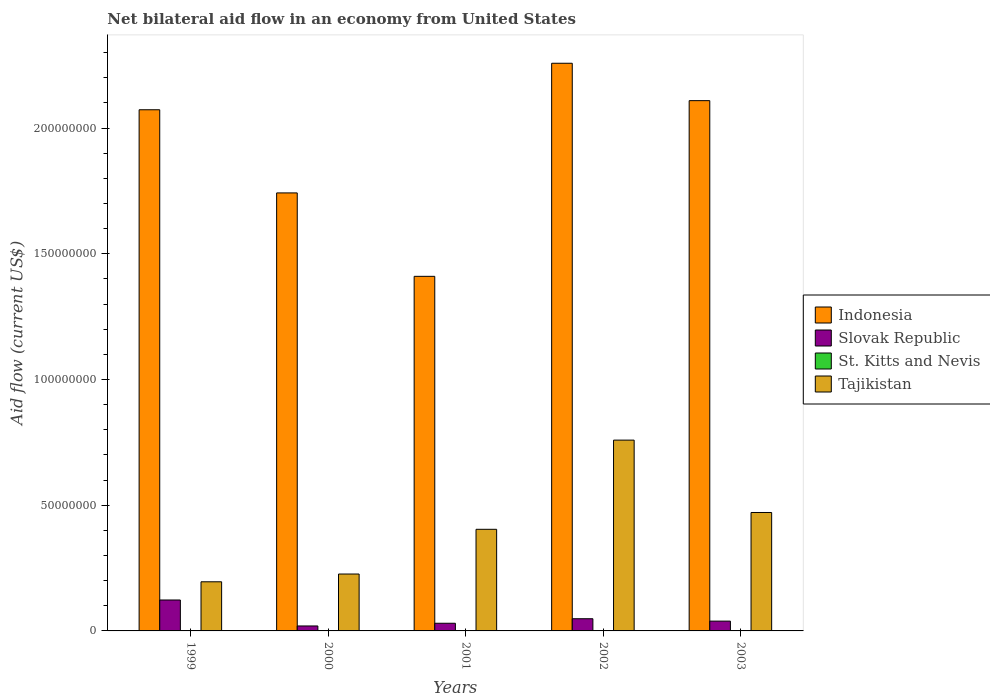How many groups of bars are there?
Offer a terse response. 5. Are the number of bars per tick equal to the number of legend labels?
Your response must be concise. No. In how many cases, is the number of bars for a given year not equal to the number of legend labels?
Provide a succinct answer. 5. What is the net bilateral aid flow in Tajikistan in 2001?
Offer a terse response. 4.04e+07. Across all years, what is the maximum net bilateral aid flow in Slovak Republic?
Give a very brief answer. 1.23e+07. Across all years, what is the minimum net bilateral aid flow in Tajikistan?
Provide a short and direct response. 1.95e+07. In which year was the net bilateral aid flow in Tajikistan maximum?
Give a very brief answer. 2002. What is the total net bilateral aid flow in Tajikistan in the graph?
Your answer should be very brief. 2.06e+08. What is the difference between the net bilateral aid flow in Tajikistan in 2002 and that in 2003?
Provide a succinct answer. 2.88e+07. What is the difference between the net bilateral aid flow in Indonesia in 2000 and the net bilateral aid flow in Slovak Republic in 2003?
Give a very brief answer. 1.70e+08. What is the average net bilateral aid flow in Indonesia per year?
Provide a succinct answer. 1.92e+08. In the year 1999, what is the difference between the net bilateral aid flow in Slovak Republic and net bilateral aid flow in Indonesia?
Ensure brevity in your answer.  -1.95e+08. What is the ratio of the net bilateral aid flow in Indonesia in 2002 to that in 2003?
Give a very brief answer. 1.07. Is the difference between the net bilateral aid flow in Slovak Republic in 2002 and 2003 greater than the difference between the net bilateral aid flow in Indonesia in 2002 and 2003?
Give a very brief answer. No. What is the difference between the highest and the second highest net bilateral aid flow in Indonesia?
Make the answer very short. 1.49e+07. What is the difference between the highest and the lowest net bilateral aid flow in Tajikistan?
Give a very brief answer. 5.63e+07. Is the sum of the net bilateral aid flow in Tajikistan in 2000 and 2002 greater than the maximum net bilateral aid flow in Indonesia across all years?
Give a very brief answer. No. Is it the case that in every year, the sum of the net bilateral aid flow in Slovak Republic and net bilateral aid flow in St. Kitts and Nevis is greater than the sum of net bilateral aid flow in Tajikistan and net bilateral aid flow in Indonesia?
Your response must be concise. No. Is it the case that in every year, the sum of the net bilateral aid flow in Slovak Republic and net bilateral aid flow in Indonesia is greater than the net bilateral aid flow in Tajikistan?
Ensure brevity in your answer.  Yes. How many years are there in the graph?
Give a very brief answer. 5. What is the difference between two consecutive major ticks on the Y-axis?
Provide a succinct answer. 5.00e+07. Are the values on the major ticks of Y-axis written in scientific E-notation?
Give a very brief answer. No. Does the graph contain grids?
Offer a very short reply. No. How many legend labels are there?
Your answer should be compact. 4. How are the legend labels stacked?
Your response must be concise. Vertical. What is the title of the graph?
Provide a short and direct response. Net bilateral aid flow in an economy from United States. What is the label or title of the X-axis?
Ensure brevity in your answer.  Years. What is the Aid flow (current US$) in Indonesia in 1999?
Keep it short and to the point. 2.07e+08. What is the Aid flow (current US$) in Slovak Republic in 1999?
Keep it short and to the point. 1.23e+07. What is the Aid flow (current US$) of Tajikistan in 1999?
Offer a terse response. 1.95e+07. What is the Aid flow (current US$) in Indonesia in 2000?
Offer a very short reply. 1.74e+08. What is the Aid flow (current US$) in Slovak Republic in 2000?
Your answer should be compact. 1.97e+06. What is the Aid flow (current US$) in Tajikistan in 2000?
Offer a very short reply. 2.26e+07. What is the Aid flow (current US$) in Indonesia in 2001?
Provide a succinct answer. 1.41e+08. What is the Aid flow (current US$) in Slovak Republic in 2001?
Your response must be concise. 3.05e+06. What is the Aid flow (current US$) in St. Kitts and Nevis in 2001?
Your answer should be very brief. 0. What is the Aid flow (current US$) in Tajikistan in 2001?
Provide a short and direct response. 4.04e+07. What is the Aid flow (current US$) in Indonesia in 2002?
Offer a terse response. 2.26e+08. What is the Aid flow (current US$) in Slovak Republic in 2002?
Provide a succinct answer. 4.85e+06. What is the Aid flow (current US$) of Tajikistan in 2002?
Ensure brevity in your answer.  7.59e+07. What is the Aid flow (current US$) in Indonesia in 2003?
Keep it short and to the point. 2.11e+08. What is the Aid flow (current US$) of Slovak Republic in 2003?
Make the answer very short. 3.90e+06. What is the Aid flow (current US$) of Tajikistan in 2003?
Your response must be concise. 4.71e+07. Across all years, what is the maximum Aid flow (current US$) of Indonesia?
Keep it short and to the point. 2.26e+08. Across all years, what is the maximum Aid flow (current US$) in Slovak Republic?
Offer a terse response. 1.23e+07. Across all years, what is the maximum Aid flow (current US$) in Tajikistan?
Make the answer very short. 7.59e+07. Across all years, what is the minimum Aid flow (current US$) in Indonesia?
Give a very brief answer. 1.41e+08. Across all years, what is the minimum Aid flow (current US$) of Slovak Republic?
Your response must be concise. 1.97e+06. Across all years, what is the minimum Aid flow (current US$) of Tajikistan?
Your answer should be very brief. 1.95e+07. What is the total Aid flow (current US$) of Indonesia in the graph?
Make the answer very short. 9.59e+08. What is the total Aid flow (current US$) in Slovak Republic in the graph?
Offer a very short reply. 2.61e+07. What is the total Aid flow (current US$) in Tajikistan in the graph?
Keep it short and to the point. 2.06e+08. What is the difference between the Aid flow (current US$) in Indonesia in 1999 and that in 2000?
Make the answer very short. 3.31e+07. What is the difference between the Aid flow (current US$) in Slovak Republic in 1999 and that in 2000?
Offer a terse response. 1.03e+07. What is the difference between the Aid flow (current US$) in Tajikistan in 1999 and that in 2000?
Your answer should be very brief. -3.09e+06. What is the difference between the Aid flow (current US$) in Indonesia in 1999 and that in 2001?
Offer a terse response. 6.62e+07. What is the difference between the Aid flow (current US$) of Slovak Republic in 1999 and that in 2001?
Provide a short and direct response. 9.25e+06. What is the difference between the Aid flow (current US$) of Tajikistan in 1999 and that in 2001?
Offer a terse response. -2.09e+07. What is the difference between the Aid flow (current US$) in Indonesia in 1999 and that in 2002?
Offer a very short reply. -1.85e+07. What is the difference between the Aid flow (current US$) of Slovak Republic in 1999 and that in 2002?
Offer a very short reply. 7.45e+06. What is the difference between the Aid flow (current US$) of Tajikistan in 1999 and that in 2002?
Offer a terse response. -5.63e+07. What is the difference between the Aid flow (current US$) in Indonesia in 1999 and that in 2003?
Offer a very short reply. -3.62e+06. What is the difference between the Aid flow (current US$) in Slovak Republic in 1999 and that in 2003?
Ensure brevity in your answer.  8.40e+06. What is the difference between the Aid flow (current US$) of Tajikistan in 1999 and that in 2003?
Provide a succinct answer. -2.76e+07. What is the difference between the Aid flow (current US$) of Indonesia in 2000 and that in 2001?
Keep it short and to the point. 3.32e+07. What is the difference between the Aid flow (current US$) of Slovak Republic in 2000 and that in 2001?
Provide a succinct answer. -1.08e+06. What is the difference between the Aid flow (current US$) of Tajikistan in 2000 and that in 2001?
Make the answer very short. -1.78e+07. What is the difference between the Aid flow (current US$) of Indonesia in 2000 and that in 2002?
Give a very brief answer. -5.16e+07. What is the difference between the Aid flow (current US$) of Slovak Republic in 2000 and that in 2002?
Give a very brief answer. -2.88e+06. What is the difference between the Aid flow (current US$) in Tajikistan in 2000 and that in 2002?
Offer a terse response. -5.32e+07. What is the difference between the Aid flow (current US$) of Indonesia in 2000 and that in 2003?
Provide a short and direct response. -3.67e+07. What is the difference between the Aid flow (current US$) of Slovak Republic in 2000 and that in 2003?
Your answer should be compact. -1.93e+06. What is the difference between the Aid flow (current US$) of Tajikistan in 2000 and that in 2003?
Provide a short and direct response. -2.45e+07. What is the difference between the Aid flow (current US$) of Indonesia in 2001 and that in 2002?
Your answer should be compact. -8.47e+07. What is the difference between the Aid flow (current US$) in Slovak Republic in 2001 and that in 2002?
Your answer should be compact. -1.80e+06. What is the difference between the Aid flow (current US$) of Tajikistan in 2001 and that in 2002?
Give a very brief answer. -3.55e+07. What is the difference between the Aid flow (current US$) of Indonesia in 2001 and that in 2003?
Provide a succinct answer. -6.99e+07. What is the difference between the Aid flow (current US$) of Slovak Republic in 2001 and that in 2003?
Keep it short and to the point. -8.50e+05. What is the difference between the Aid flow (current US$) in Tajikistan in 2001 and that in 2003?
Provide a succinct answer. -6.69e+06. What is the difference between the Aid flow (current US$) of Indonesia in 2002 and that in 2003?
Your answer should be compact. 1.49e+07. What is the difference between the Aid flow (current US$) in Slovak Republic in 2002 and that in 2003?
Offer a very short reply. 9.50e+05. What is the difference between the Aid flow (current US$) in Tajikistan in 2002 and that in 2003?
Offer a very short reply. 2.88e+07. What is the difference between the Aid flow (current US$) in Indonesia in 1999 and the Aid flow (current US$) in Slovak Republic in 2000?
Offer a very short reply. 2.05e+08. What is the difference between the Aid flow (current US$) of Indonesia in 1999 and the Aid flow (current US$) of Tajikistan in 2000?
Keep it short and to the point. 1.85e+08. What is the difference between the Aid flow (current US$) in Slovak Republic in 1999 and the Aid flow (current US$) in Tajikistan in 2000?
Offer a very short reply. -1.03e+07. What is the difference between the Aid flow (current US$) of Indonesia in 1999 and the Aid flow (current US$) of Slovak Republic in 2001?
Make the answer very short. 2.04e+08. What is the difference between the Aid flow (current US$) in Indonesia in 1999 and the Aid flow (current US$) in Tajikistan in 2001?
Keep it short and to the point. 1.67e+08. What is the difference between the Aid flow (current US$) of Slovak Republic in 1999 and the Aid flow (current US$) of Tajikistan in 2001?
Keep it short and to the point. -2.81e+07. What is the difference between the Aid flow (current US$) in Indonesia in 1999 and the Aid flow (current US$) in Slovak Republic in 2002?
Offer a very short reply. 2.02e+08. What is the difference between the Aid flow (current US$) in Indonesia in 1999 and the Aid flow (current US$) in Tajikistan in 2002?
Offer a terse response. 1.31e+08. What is the difference between the Aid flow (current US$) of Slovak Republic in 1999 and the Aid flow (current US$) of Tajikistan in 2002?
Keep it short and to the point. -6.36e+07. What is the difference between the Aid flow (current US$) in Indonesia in 1999 and the Aid flow (current US$) in Slovak Republic in 2003?
Keep it short and to the point. 2.03e+08. What is the difference between the Aid flow (current US$) in Indonesia in 1999 and the Aid flow (current US$) in Tajikistan in 2003?
Make the answer very short. 1.60e+08. What is the difference between the Aid flow (current US$) of Slovak Republic in 1999 and the Aid flow (current US$) of Tajikistan in 2003?
Ensure brevity in your answer.  -3.48e+07. What is the difference between the Aid flow (current US$) of Indonesia in 2000 and the Aid flow (current US$) of Slovak Republic in 2001?
Offer a terse response. 1.71e+08. What is the difference between the Aid flow (current US$) of Indonesia in 2000 and the Aid flow (current US$) of Tajikistan in 2001?
Your answer should be compact. 1.34e+08. What is the difference between the Aid flow (current US$) in Slovak Republic in 2000 and the Aid flow (current US$) in Tajikistan in 2001?
Offer a terse response. -3.84e+07. What is the difference between the Aid flow (current US$) of Indonesia in 2000 and the Aid flow (current US$) of Slovak Republic in 2002?
Offer a very short reply. 1.69e+08. What is the difference between the Aid flow (current US$) of Indonesia in 2000 and the Aid flow (current US$) of Tajikistan in 2002?
Offer a terse response. 9.83e+07. What is the difference between the Aid flow (current US$) in Slovak Republic in 2000 and the Aid flow (current US$) in Tajikistan in 2002?
Provide a short and direct response. -7.39e+07. What is the difference between the Aid flow (current US$) of Indonesia in 2000 and the Aid flow (current US$) of Slovak Republic in 2003?
Your response must be concise. 1.70e+08. What is the difference between the Aid flow (current US$) in Indonesia in 2000 and the Aid flow (current US$) in Tajikistan in 2003?
Your response must be concise. 1.27e+08. What is the difference between the Aid flow (current US$) of Slovak Republic in 2000 and the Aid flow (current US$) of Tajikistan in 2003?
Your response must be concise. -4.51e+07. What is the difference between the Aid flow (current US$) of Indonesia in 2001 and the Aid flow (current US$) of Slovak Republic in 2002?
Your response must be concise. 1.36e+08. What is the difference between the Aid flow (current US$) of Indonesia in 2001 and the Aid flow (current US$) of Tajikistan in 2002?
Offer a very short reply. 6.51e+07. What is the difference between the Aid flow (current US$) of Slovak Republic in 2001 and the Aid flow (current US$) of Tajikistan in 2002?
Offer a terse response. -7.28e+07. What is the difference between the Aid flow (current US$) of Indonesia in 2001 and the Aid flow (current US$) of Slovak Republic in 2003?
Ensure brevity in your answer.  1.37e+08. What is the difference between the Aid flow (current US$) of Indonesia in 2001 and the Aid flow (current US$) of Tajikistan in 2003?
Offer a very short reply. 9.39e+07. What is the difference between the Aid flow (current US$) of Slovak Republic in 2001 and the Aid flow (current US$) of Tajikistan in 2003?
Keep it short and to the point. -4.40e+07. What is the difference between the Aid flow (current US$) of Indonesia in 2002 and the Aid flow (current US$) of Slovak Republic in 2003?
Your answer should be compact. 2.22e+08. What is the difference between the Aid flow (current US$) of Indonesia in 2002 and the Aid flow (current US$) of Tajikistan in 2003?
Keep it short and to the point. 1.79e+08. What is the difference between the Aid flow (current US$) of Slovak Republic in 2002 and the Aid flow (current US$) of Tajikistan in 2003?
Offer a terse response. -4.22e+07. What is the average Aid flow (current US$) in Indonesia per year?
Your answer should be compact. 1.92e+08. What is the average Aid flow (current US$) of Slovak Republic per year?
Give a very brief answer. 5.21e+06. What is the average Aid flow (current US$) in St. Kitts and Nevis per year?
Your answer should be very brief. 0. What is the average Aid flow (current US$) in Tajikistan per year?
Offer a terse response. 4.11e+07. In the year 1999, what is the difference between the Aid flow (current US$) of Indonesia and Aid flow (current US$) of Slovak Republic?
Keep it short and to the point. 1.95e+08. In the year 1999, what is the difference between the Aid flow (current US$) in Indonesia and Aid flow (current US$) in Tajikistan?
Give a very brief answer. 1.88e+08. In the year 1999, what is the difference between the Aid flow (current US$) of Slovak Republic and Aid flow (current US$) of Tajikistan?
Provide a short and direct response. -7.24e+06. In the year 2000, what is the difference between the Aid flow (current US$) of Indonesia and Aid flow (current US$) of Slovak Republic?
Ensure brevity in your answer.  1.72e+08. In the year 2000, what is the difference between the Aid flow (current US$) in Indonesia and Aid flow (current US$) in Tajikistan?
Offer a terse response. 1.52e+08. In the year 2000, what is the difference between the Aid flow (current US$) in Slovak Republic and Aid flow (current US$) in Tajikistan?
Your response must be concise. -2.07e+07. In the year 2001, what is the difference between the Aid flow (current US$) of Indonesia and Aid flow (current US$) of Slovak Republic?
Give a very brief answer. 1.38e+08. In the year 2001, what is the difference between the Aid flow (current US$) in Indonesia and Aid flow (current US$) in Tajikistan?
Ensure brevity in your answer.  1.01e+08. In the year 2001, what is the difference between the Aid flow (current US$) in Slovak Republic and Aid flow (current US$) in Tajikistan?
Give a very brief answer. -3.74e+07. In the year 2002, what is the difference between the Aid flow (current US$) of Indonesia and Aid flow (current US$) of Slovak Republic?
Keep it short and to the point. 2.21e+08. In the year 2002, what is the difference between the Aid flow (current US$) in Indonesia and Aid flow (current US$) in Tajikistan?
Ensure brevity in your answer.  1.50e+08. In the year 2002, what is the difference between the Aid flow (current US$) in Slovak Republic and Aid flow (current US$) in Tajikistan?
Provide a succinct answer. -7.10e+07. In the year 2003, what is the difference between the Aid flow (current US$) of Indonesia and Aid flow (current US$) of Slovak Republic?
Keep it short and to the point. 2.07e+08. In the year 2003, what is the difference between the Aid flow (current US$) of Indonesia and Aid flow (current US$) of Tajikistan?
Give a very brief answer. 1.64e+08. In the year 2003, what is the difference between the Aid flow (current US$) of Slovak Republic and Aid flow (current US$) of Tajikistan?
Ensure brevity in your answer.  -4.32e+07. What is the ratio of the Aid flow (current US$) in Indonesia in 1999 to that in 2000?
Your response must be concise. 1.19. What is the ratio of the Aid flow (current US$) in Slovak Republic in 1999 to that in 2000?
Offer a terse response. 6.24. What is the ratio of the Aid flow (current US$) in Tajikistan in 1999 to that in 2000?
Your answer should be very brief. 0.86. What is the ratio of the Aid flow (current US$) of Indonesia in 1999 to that in 2001?
Ensure brevity in your answer.  1.47. What is the ratio of the Aid flow (current US$) of Slovak Republic in 1999 to that in 2001?
Offer a very short reply. 4.03. What is the ratio of the Aid flow (current US$) in Tajikistan in 1999 to that in 2001?
Provide a short and direct response. 0.48. What is the ratio of the Aid flow (current US$) in Indonesia in 1999 to that in 2002?
Provide a succinct answer. 0.92. What is the ratio of the Aid flow (current US$) of Slovak Republic in 1999 to that in 2002?
Your response must be concise. 2.54. What is the ratio of the Aid flow (current US$) in Tajikistan in 1999 to that in 2002?
Make the answer very short. 0.26. What is the ratio of the Aid flow (current US$) of Indonesia in 1999 to that in 2003?
Provide a succinct answer. 0.98. What is the ratio of the Aid flow (current US$) in Slovak Republic in 1999 to that in 2003?
Ensure brevity in your answer.  3.15. What is the ratio of the Aid flow (current US$) in Tajikistan in 1999 to that in 2003?
Keep it short and to the point. 0.41. What is the ratio of the Aid flow (current US$) of Indonesia in 2000 to that in 2001?
Offer a very short reply. 1.24. What is the ratio of the Aid flow (current US$) in Slovak Republic in 2000 to that in 2001?
Ensure brevity in your answer.  0.65. What is the ratio of the Aid flow (current US$) in Tajikistan in 2000 to that in 2001?
Your answer should be very brief. 0.56. What is the ratio of the Aid flow (current US$) in Indonesia in 2000 to that in 2002?
Provide a succinct answer. 0.77. What is the ratio of the Aid flow (current US$) of Slovak Republic in 2000 to that in 2002?
Give a very brief answer. 0.41. What is the ratio of the Aid flow (current US$) of Tajikistan in 2000 to that in 2002?
Keep it short and to the point. 0.3. What is the ratio of the Aid flow (current US$) in Indonesia in 2000 to that in 2003?
Make the answer very short. 0.83. What is the ratio of the Aid flow (current US$) in Slovak Republic in 2000 to that in 2003?
Make the answer very short. 0.51. What is the ratio of the Aid flow (current US$) of Tajikistan in 2000 to that in 2003?
Provide a short and direct response. 0.48. What is the ratio of the Aid flow (current US$) of Indonesia in 2001 to that in 2002?
Offer a very short reply. 0.62. What is the ratio of the Aid flow (current US$) of Slovak Republic in 2001 to that in 2002?
Give a very brief answer. 0.63. What is the ratio of the Aid flow (current US$) of Tajikistan in 2001 to that in 2002?
Provide a succinct answer. 0.53. What is the ratio of the Aid flow (current US$) in Indonesia in 2001 to that in 2003?
Your answer should be compact. 0.67. What is the ratio of the Aid flow (current US$) in Slovak Republic in 2001 to that in 2003?
Offer a terse response. 0.78. What is the ratio of the Aid flow (current US$) of Tajikistan in 2001 to that in 2003?
Ensure brevity in your answer.  0.86. What is the ratio of the Aid flow (current US$) in Indonesia in 2002 to that in 2003?
Offer a very short reply. 1.07. What is the ratio of the Aid flow (current US$) in Slovak Republic in 2002 to that in 2003?
Ensure brevity in your answer.  1.24. What is the ratio of the Aid flow (current US$) of Tajikistan in 2002 to that in 2003?
Keep it short and to the point. 1.61. What is the difference between the highest and the second highest Aid flow (current US$) in Indonesia?
Provide a succinct answer. 1.49e+07. What is the difference between the highest and the second highest Aid flow (current US$) of Slovak Republic?
Make the answer very short. 7.45e+06. What is the difference between the highest and the second highest Aid flow (current US$) in Tajikistan?
Offer a very short reply. 2.88e+07. What is the difference between the highest and the lowest Aid flow (current US$) in Indonesia?
Keep it short and to the point. 8.47e+07. What is the difference between the highest and the lowest Aid flow (current US$) in Slovak Republic?
Ensure brevity in your answer.  1.03e+07. What is the difference between the highest and the lowest Aid flow (current US$) in Tajikistan?
Your answer should be compact. 5.63e+07. 